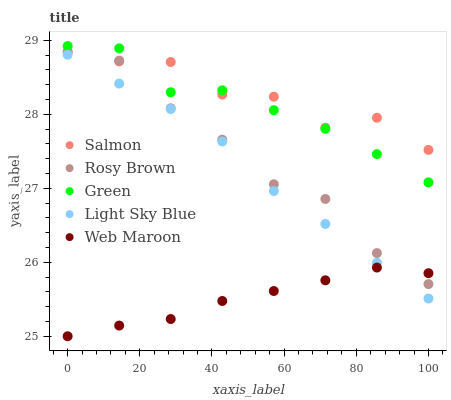Does Web Maroon have the minimum area under the curve?
Answer yes or no. Yes. Does Salmon have the maximum area under the curve?
Answer yes or no. Yes. Does Green have the minimum area under the curve?
Answer yes or no. No. Does Green have the maximum area under the curve?
Answer yes or no. No. Is Web Maroon the smoothest?
Answer yes or no. Yes. Is Salmon the roughest?
Answer yes or no. Yes. Is Green the smoothest?
Answer yes or no. No. Is Green the roughest?
Answer yes or no. No. Does Web Maroon have the lowest value?
Answer yes or no. Yes. Does Green have the lowest value?
Answer yes or no. No. Does Green have the highest value?
Answer yes or no. Yes. Does Rosy Brown have the highest value?
Answer yes or no. No. Is Light Sky Blue less than Green?
Answer yes or no. Yes. Is Salmon greater than Light Sky Blue?
Answer yes or no. Yes. Does Salmon intersect Green?
Answer yes or no. Yes. Is Salmon less than Green?
Answer yes or no. No. Is Salmon greater than Green?
Answer yes or no. No. Does Light Sky Blue intersect Green?
Answer yes or no. No. 